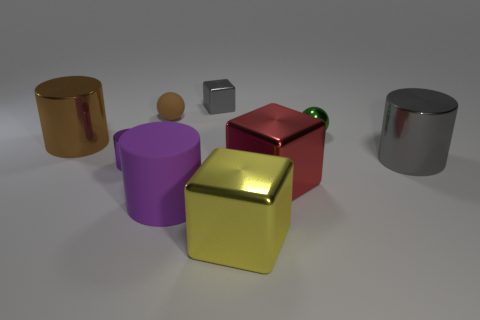Do the green metal sphere and the gray cube have the same size?
Give a very brief answer. Yes. What number of objects are either large brown things or tiny metallic things left of the large red metal object?
Give a very brief answer. 3. What number of things are tiny spheres behind the green object or shiny objects that are on the right side of the tiny cube?
Provide a short and direct response. 5. There is a red metallic object; are there any purple objects on the right side of it?
Make the answer very short. No. There is a tiny object in front of the cylinder behind the metallic thing that is right of the green ball; what is its color?
Your answer should be compact. Purple. Do the yellow thing and the small green metallic object have the same shape?
Your response must be concise. No. There is another small cylinder that is the same material as the brown cylinder; what is its color?
Give a very brief answer. Purple. What number of objects are either large metallic objects left of the green metallic sphere or big purple matte things?
Give a very brief answer. 4. What is the size of the gray thing that is on the right side of the green sphere?
Your answer should be compact. Large. Do the purple rubber cylinder and the gray thing in front of the big brown cylinder have the same size?
Your answer should be very brief. Yes. 